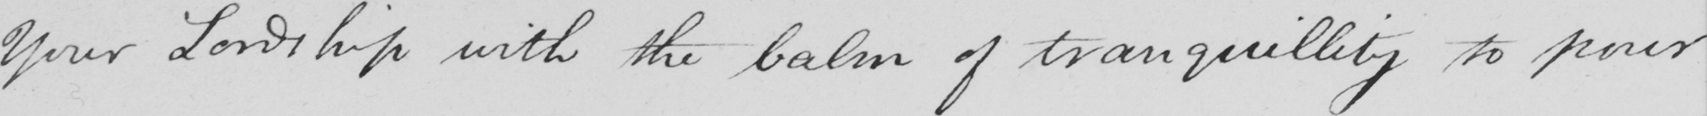What text is written in this handwritten line? Your Lordship with the balm of tranquillity to pour 